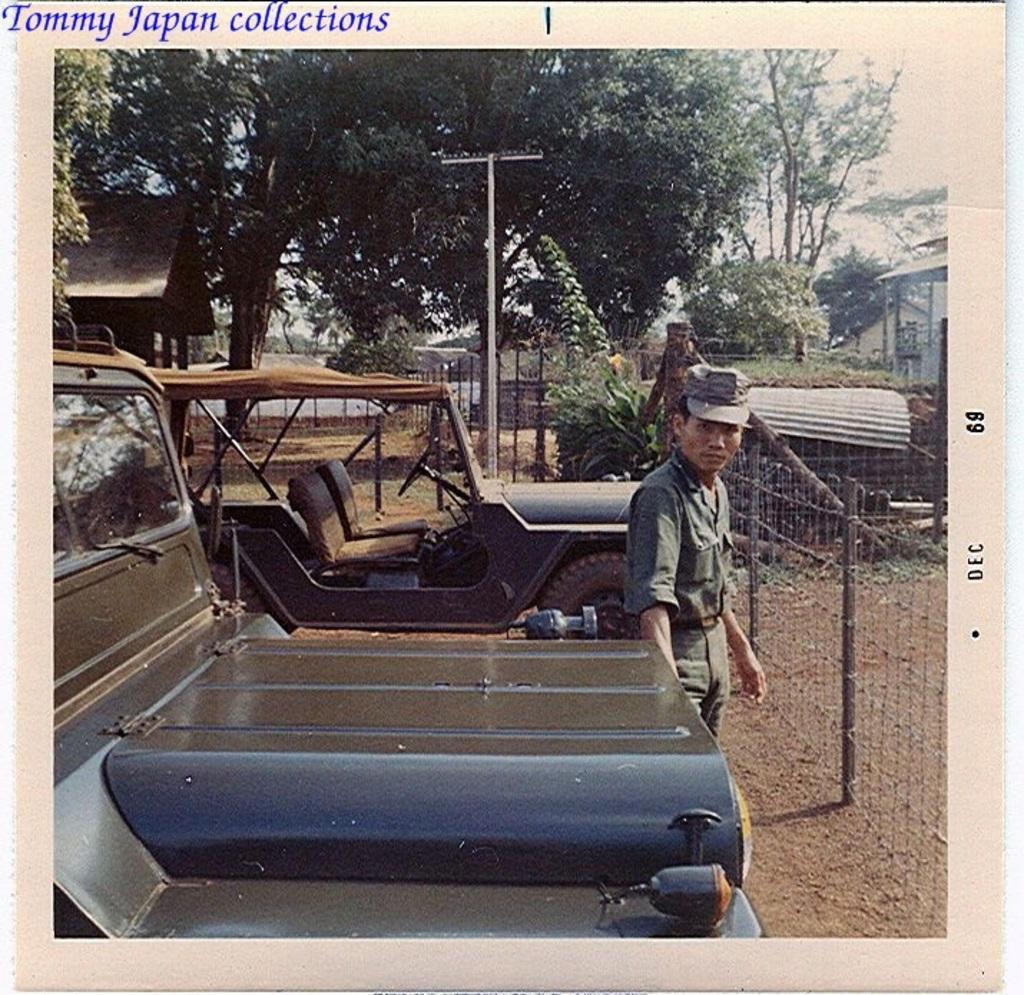In one or two sentences, can you explain what this image depicts? In this image we can see there are two vehicles parked and a person is standing in front of it, in the background there are trees, railings, plants, poles and houses. 